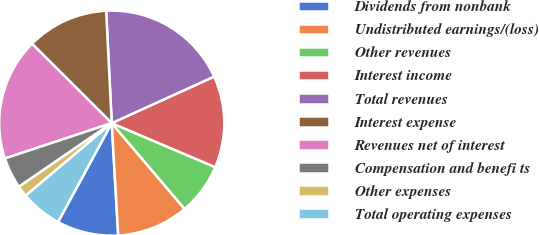Convert chart. <chart><loc_0><loc_0><loc_500><loc_500><pie_chart><fcel>Dividends from nonbank<fcel>Undistributed earnings/(loss)<fcel>Other revenues<fcel>Interest income<fcel>Total revenues<fcel>Interest expense<fcel>Revenues net of interest<fcel>Compensation and benefi ts<fcel>Other expenses<fcel>Total operating expenses<nl><fcel>8.84%<fcel>10.29%<fcel>7.39%<fcel>13.19%<fcel>19.0%<fcel>11.74%<fcel>17.55%<fcel>4.48%<fcel>1.58%<fcel>5.93%<nl></chart> 